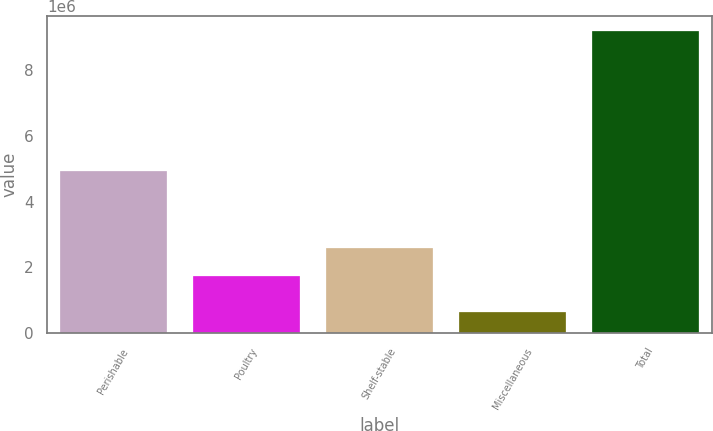Convert chart to OTSL. <chart><loc_0><loc_0><loc_500><loc_500><bar_chart><fcel>Perishable<fcel>Poultry<fcel>Shelf-stable<fcel>Miscellaneous<fcel>Total<nl><fcel>4.92296e+06<fcel>1.751e+06<fcel>2.60358e+06<fcel>641726<fcel>9.16752e+06<nl></chart> 